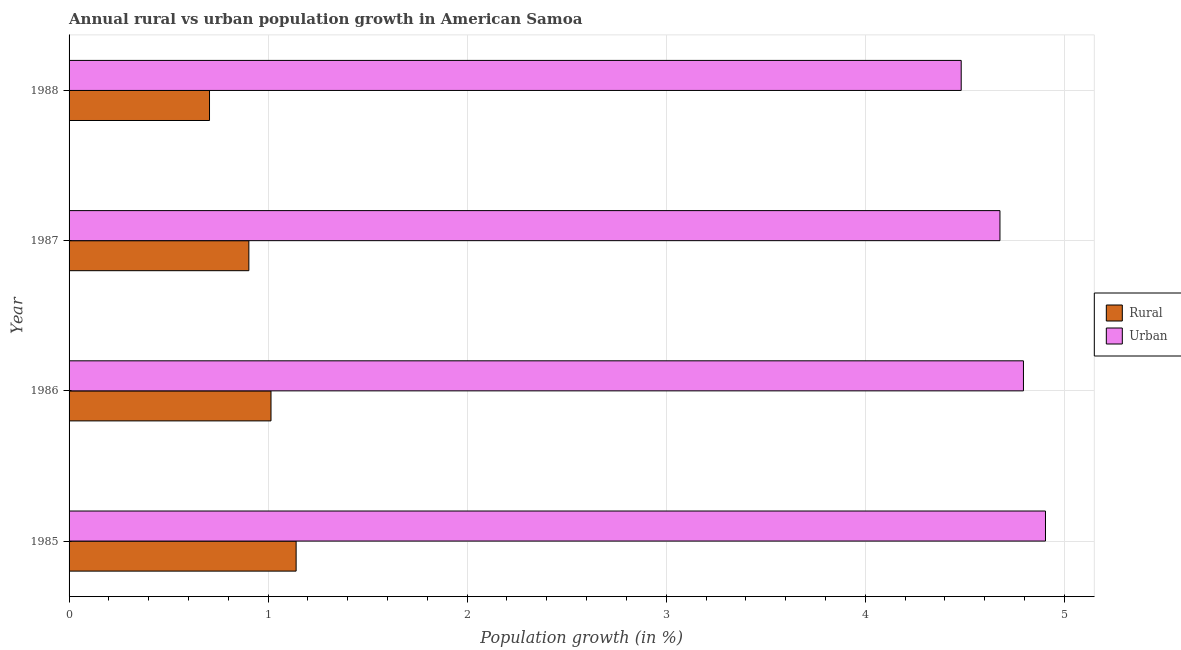How many different coloured bars are there?
Offer a very short reply. 2. How many groups of bars are there?
Make the answer very short. 4. Are the number of bars per tick equal to the number of legend labels?
Your answer should be very brief. Yes. How many bars are there on the 4th tick from the bottom?
Your answer should be compact. 2. What is the label of the 4th group of bars from the top?
Your response must be concise. 1985. What is the urban population growth in 1986?
Offer a terse response. 4.79. Across all years, what is the maximum urban population growth?
Provide a succinct answer. 4.91. Across all years, what is the minimum urban population growth?
Offer a terse response. 4.48. In which year was the rural population growth minimum?
Keep it short and to the point. 1988. What is the total urban population growth in the graph?
Your answer should be compact. 18.86. What is the difference between the rural population growth in 1985 and that in 1986?
Ensure brevity in your answer.  0.13. What is the difference between the urban population growth in 1985 and the rural population growth in 1988?
Offer a terse response. 4.2. What is the average rural population growth per year?
Ensure brevity in your answer.  0.94. In the year 1985, what is the difference between the urban population growth and rural population growth?
Keep it short and to the point. 3.77. What is the ratio of the urban population growth in 1986 to that in 1988?
Offer a very short reply. 1.07. What is the difference between the highest and the second highest rural population growth?
Offer a very short reply. 0.13. What is the difference between the highest and the lowest urban population growth?
Keep it short and to the point. 0.42. In how many years, is the urban population growth greater than the average urban population growth taken over all years?
Your answer should be very brief. 2. Is the sum of the urban population growth in 1985 and 1988 greater than the maximum rural population growth across all years?
Keep it short and to the point. Yes. What does the 2nd bar from the top in 1985 represents?
Your response must be concise. Rural. What does the 2nd bar from the bottom in 1985 represents?
Your answer should be very brief. Urban . How many years are there in the graph?
Provide a short and direct response. 4. Does the graph contain grids?
Your answer should be very brief. Yes. Where does the legend appear in the graph?
Offer a terse response. Center right. How many legend labels are there?
Ensure brevity in your answer.  2. How are the legend labels stacked?
Your response must be concise. Vertical. What is the title of the graph?
Offer a very short reply. Annual rural vs urban population growth in American Samoa. What is the label or title of the X-axis?
Your response must be concise. Population growth (in %). What is the Population growth (in %) of Rural in 1985?
Give a very brief answer. 1.14. What is the Population growth (in %) in Urban  in 1985?
Ensure brevity in your answer.  4.91. What is the Population growth (in %) in Rural in 1986?
Keep it short and to the point. 1.01. What is the Population growth (in %) of Urban  in 1986?
Ensure brevity in your answer.  4.79. What is the Population growth (in %) in Rural in 1987?
Offer a very short reply. 0.9. What is the Population growth (in %) of Urban  in 1987?
Make the answer very short. 4.68. What is the Population growth (in %) of Rural in 1988?
Offer a terse response. 0.71. What is the Population growth (in %) in Urban  in 1988?
Keep it short and to the point. 4.48. Across all years, what is the maximum Population growth (in %) of Rural?
Your answer should be very brief. 1.14. Across all years, what is the maximum Population growth (in %) of Urban ?
Provide a short and direct response. 4.91. Across all years, what is the minimum Population growth (in %) of Rural?
Give a very brief answer. 0.71. Across all years, what is the minimum Population growth (in %) of Urban ?
Your response must be concise. 4.48. What is the total Population growth (in %) in Rural in the graph?
Your answer should be very brief. 3.76. What is the total Population growth (in %) of Urban  in the graph?
Offer a terse response. 18.86. What is the difference between the Population growth (in %) of Rural in 1985 and that in 1986?
Keep it short and to the point. 0.13. What is the difference between the Population growth (in %) in Urban  in 1985 and that in 1986?
Ensure brevity in your answer.  0.11. What is the difference between the Population growth (in %) of Rural in 1985 and that in 1987?
Offer a terse response. 0.24. What is the difference between the Population growth (in %) in Urban  in 1985 and that in 1987?
Your response must be concise. 0.23. What is the difference between the Population growth (in %) of Rural in 1985 and that in 1988?
Offer a very short reply. 0.44. What is the difference between the Population growth (in %) in Urban  in 1985 and that in 1988?
Provide a succinct answer. 0.42. What is the difference between the Population growth (in %) of Rural in 1986 and that in 1987?
Offer a terse response. 0.11. What is the difference between the Population growth (in %) of Urban  in 1986 and that in 1987?
Provide a short and direct response. 0.12. What is the difference between the Population growth (in %) in Rural in 1986 and that in 1988?
Give a very brief answer. 0.31. What is the difference between the Population growth (in %) of Urban  in 1986 and that in 1988?
Offer a terse response. 0.31. What is the difference between the Population growth (in %) in Rural in 1987 and that in 1988?
Give a very brief answer. 0.2. What is the difference between the Population growth (in %) in Urban  in 1987 and that in 1988?
Your response must be concise. 0.19. What is the difference between the Population growth (in %) in Rural in 1985 and the Population growth (in %) in Urban  in 1986?
Your answer should be compact. -3.65. What is the difference between the Population growth (in %) in Rural in 1985 and the Population growth (in %) in Urban  in 1987?
Provide a succinct answer. -3.54. What is the difference between the Population growth (in %) of Rural in 1985 and the Population growth (in %) of Urban  in 1988?
Offer a very short reply. -3.34. What is the difference between the Population growth (in %) of Rural in 1986 and the Population growth (in %) of Urban  in 1987?
Your response must be concise. -3.66. What is the difference between the Population growth (in %) of Rural in 1986 and the Population growth (in %) of Urban  in 1988?
Ensure brevity in your answer.  -3.47. What is the difference between the Population growth (in %) in Rural in 1987 and the Population growth (in %) in Urban  in 1988?
Keep it short and to the point. -3.58. What is the average Population growth (in %) of Rural per year?
Keep it short and to the point. 0.94. What is the average Population growth (in %) of Urban  per year?
Provide a short and direct response. 4.71. In the year 1985, what is the difference between the Population growth (in %) of Rural and Population growth (in %) of Urban ?
Provide a short and direct response. -3.76. In the year 1986, what is the difference between the Population growth (in %) of Rural and Population growth (in %) of Urban ?
Keep it short and to the point. -3.78. In the year 1987, what is the difference between the Population growth (in %) of Rural and Population growth (in %) of Urban ?
Provide a succinct answer. -3.77. In the year 1988, what is the difference between the Population growth (in %) of Rural and Population growth (in %) of Urban ?
Ensure brevity in your answer.  -3.78. What is the ratio of the Population growth (in %) in Rural in 1985 to that in 1986?
Provide a short and direct response. 1.12. What is the ratio of the Population growth (in %) in Urban  in 1985 to that in 1986?
Your answer should be very brief. 1.02. What is the ratio of the Population growth (in %) in Rural in 1985 to that in 1987?
Your response must be concise. 1.26. What is the ratio of the Population growth (in %) in Urban  in 1985 to that in 1987?
Provide a succinct answer. 1.05. What is the ratio of the Population growth (in %) in Rural in 1985 to that in 1988?
Ensure brevity in your answer.  1.62. What is the ratio of the Population growth (in %) of Urban  in 1985 to that in 1988?
Provide a succinct answer. 1.09. What is the ratio of the Population growth (in %) of Rural in 1986 to that in 1987?
Your answer should be very brief. 1.12. What is the ratio of the Population growth (in %) of Urban  in 1986 to that in 1987?
Your answer should be compact. 1.03. What is the ratio of the Population growth (in %) of Rural in 1986 to that in 1988?
Provide a short and direct response. 1.44. What is the ratio of the Population growth (in %) in Urban  in 1986 to that in 1988?
Keep it short and to the point. 1.07. What is the ratio of the Population growth (in %) in Rural in 1987 to that in 1988?
Keep it short and to the point. 1.28. What is the ratio of the Population growth (in %) of Urban  in 1987 to that in 1988?
Make the answer very short. 1.04. What is the difference between the highest and the second highest Population growth (in %) in Rural?
Your answer should be compact. 0.13. What is the difference between the highest and the second highest Population growth (in %) of Urban ?
Make the answer very short. 0.11. What is the difference between the highest and the lowest Population growth (in %) of Rural?
Offer a terse response. 0.44. What is the difference between the highest and the lowest Population growth (in %) of Urban ?
Offer a terse response. 0.42. 